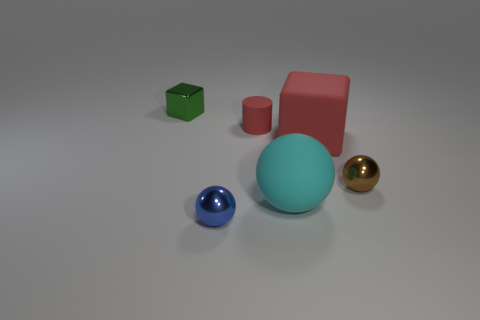How many tiny metallic balls are to the left of the large thing on the left side of the cube in front of the green metal thing?
Provide a short and direct response. 1. How many metal objects are cyan spheres or red spheres?
Offer a terse response. 0. What size is the rubber object that is in front of the cube that is on the right side of the green object?
Your answer should be compact. Large. There is a metal ball that is left of the brown sphere; is its color the same as the big object right of the cyan rubber sphere?
Your answer should be compact. No. The sphere that is both on the left side of the brown metallic sphere and right of the tiny blue metal sphere is what color?
Your answer should be very brief. Cyan. Are the small cube and the cyan thing made of the same material?
Keep it short and to the point. No. How many big things are either blue spheres or red cylinders?
Ensure brevity in your answer.  0. Are there any other things that have the same shape as the cyan matte object?
Your answer should be compact. Yes. Is there any other thing that has the same size as the green object?
Your response must be concise. Yes. What color is the tiny thing that is the same material as the large sphere?
Provide a short and direct response. Red. 